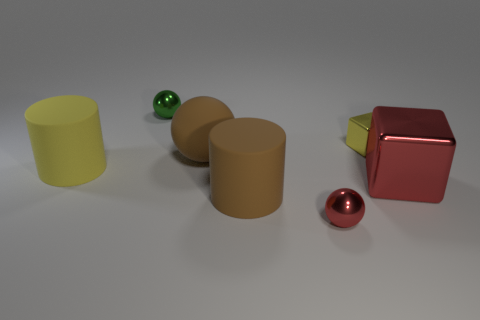Add 1 small balls. How many objects exist? 8 Subtract all blocks. How many objects are left? 5 Subtract 0 yellow spheres. How many objects are left? 7 Subtract all big blocks. Subtract all large rubber balls. How many objects are left? 5 Add 2 big red metallic blocks. How many big red metallic blocks are left? 3 Add 2 green cylinders. How many green cylinders exist? 2 